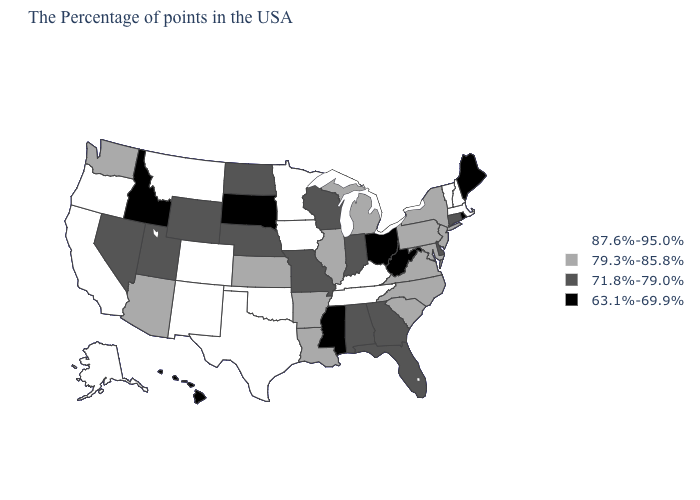What is the value of New Mexico?
Short answer required. 87.6%-95.0%. What is the lowest value in states that border New Hampshire?
Write a very short answer. 63.1%-69.9%. What is the value of Maryland?
Concise answer only. 79.3%-85.8%. Name the states that have a value in the range 87.6%-95.0%?
Give a very brief answer. Massachusetts, New Hampshire, Vermont, Kentucky, Tennessee, Minnesota, Iowa, Oklahoma, Texas, Colorado, New Mexico, Montana, California, Oregon, Alaska. Does Delaware have a lower value than Wyoming?
Quick response, please. No. Among the states that border Kansas , which have the lowest value?
Keep it brief. Missouri, Nebraska. What is the lowest value in states that border Vermont?
Short answer required. 79.3%-85.8%. Among the states that border New Mexico , does Texas have the highest value?
Answer briefly. Yes. Name the states that have a value in the range 63.1%-69.9%?
Quick response, please. Maine, Rhode Island, West Virginia, Ohio, Mississippi, South Dakota, Idaho, Hawaii. Does Rhode Island have the same value as West Virginia?
Be succinct. Yes. What is the value of Idaho?
Quick response, please. 63.1%-69.9%. What is the lowest value in the MidWest?
Be succinct. 63.1%-69.9%. Name the states that have a value in the range 63.1%-69.9%?
Quick response, please. Maine, Rhode Island, West Virginia, Ohio, Mississippi, South Dakota, Idaho, Hawaii. Name the states that have a value in the range 79.3%-85.8%?
Short answer required. New York, New Jersey, Maryland, Pennsylvania, Virginia, North Carolina, South Carolina, Michigan, Illinois, Louisiana, Arkansas, Kansas, Arizona, Washington. Does Maryland have the highest value in the USA?
Quick response, please. No. 